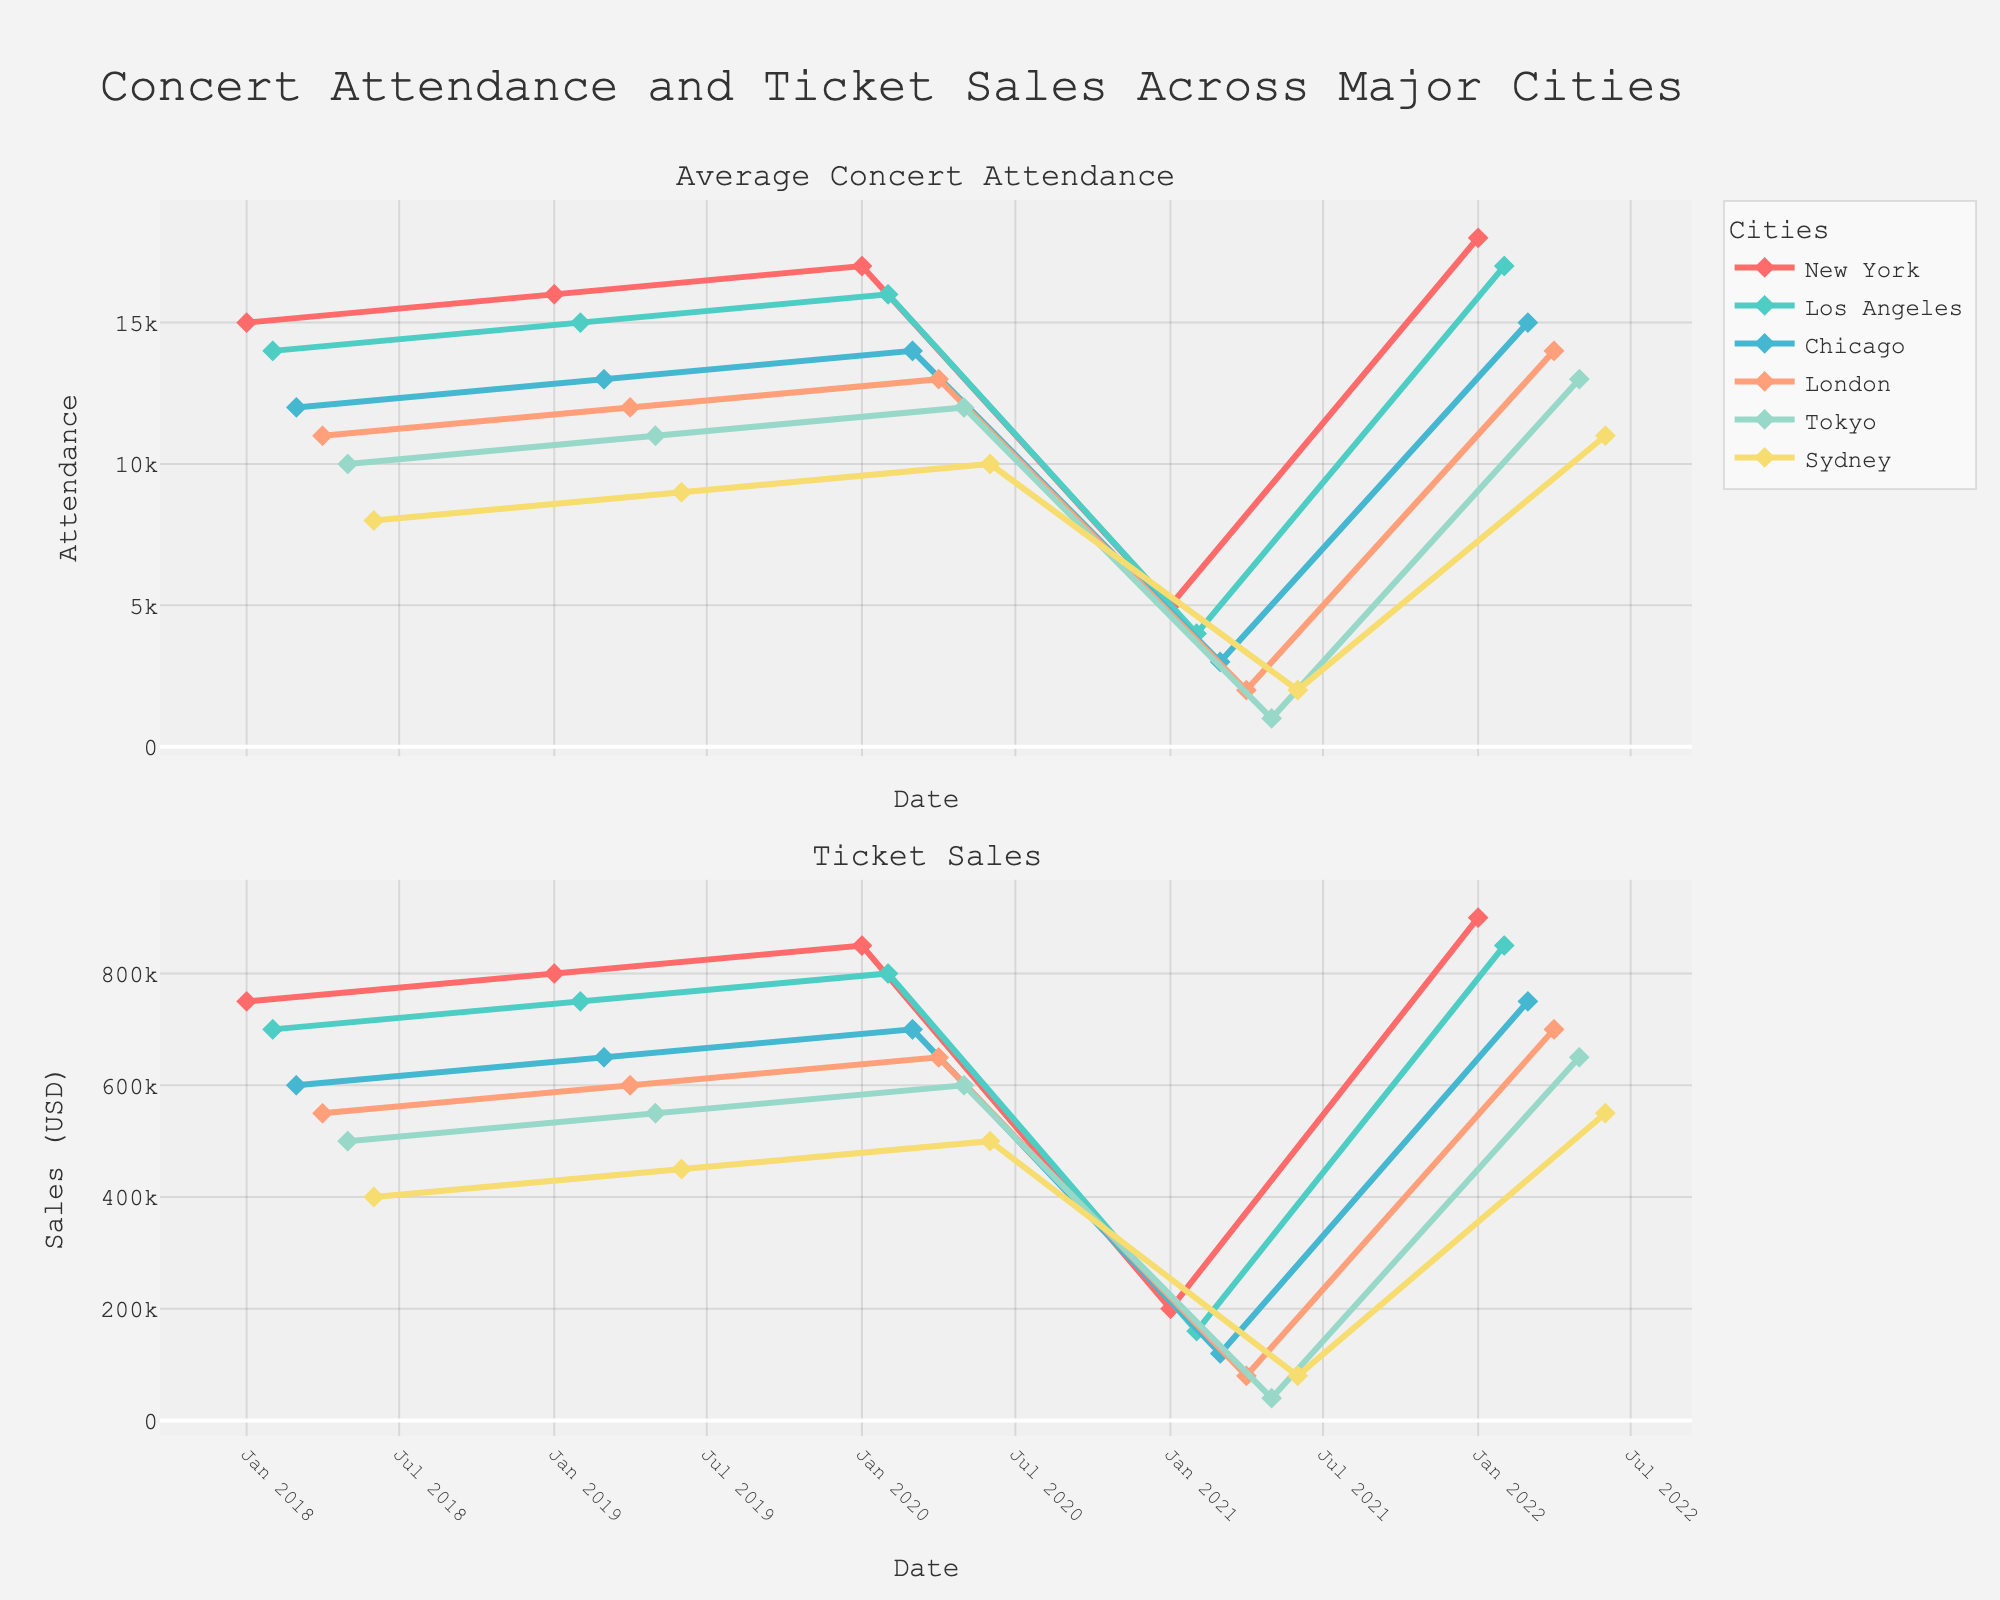What is the title of the figure? The title of the figure is located at the top and is typically in larger, bold font. We can see it reads "Concert Attendance and Ticket Sales Across Major Cities".
Answer: Concert Attendance and Ticket Sales Across Major Cities What time period does the figure cover for New York? To determine the covered time period, look at the dates on the x-axis for the "New York" data. The data points for New York span from January 2018 to January 2022.
Answer: January 2018 to January 2022 How did the concert attendance in Tokyo change from 2020 to 2021? By finding the data points for Tokyo in the upper subplot, we can see the attendance in May 2020 was 12,000 and it dropped to 1,000 in May 2021.
Answer: Dropped from 12,000 to 1,000 Which city had the lowest ticket sales in 2021 and how much was it? Observing the ticket sales plot (lower subplot), the lowest ticket sales in 2021 are seen in the spike for London. The noted sales amount was $80,000 in London (April 2021).
Answer: London, $80,000 Compare the concert attendance trends of New York and Los Angeles. Which city had a higher percentage drop in attendance in 2021 compared to 2020, and by how much? First, we calculate the drop for New York: from 17,000 (2020) to 5,000 (2021), giving a percentage drop of (17,000-5,000)/17,000 ≈ 70.59%. For Los Angeles, attendance dropped from 16,000 (2020) to 4,000 (2021), providing a percentage drop of (16,000-4,000)/16,000 = 75%. Los Angeles had the higher percentage drop by 4.41%.
Answer: Los Angeles, by 4.41% Which month and year did Sydney see a significant increase in both attendance and ticket sales compared to the previous year? Identify the month and year in the subplots where Sydney shows a jump in attendance and ticket sales compared to the previous year. The significant increase was in June 2022, compared to June 2021.
Answer: June 2022 How does the average concert attendance in 2019 compare across the cities? Refer to the points in the upper subplot for 2019. Compare the attendance figures for each city: New York (16,000), Los Angeles (15,000), Chicago (13,000), London (12,000), Tokyo (11,000), Sydney (9,000).
Answer: New York > Los Angeles > Chicago > London > Tokyo > Sydney What was the trend in ticket sales for London from 2018 to 2022? Following the trajectory of London's sales data points in the lower subplot, we can observe the ticket sales increased from 2018 to 2020, dropped significantly in 2021, and then sharply increased again in 2022.
Answer: Increase, drop, increase Considering all cities, which one had the highest concert attendance in 2022 and what was the figure? In the earliest time points of 2022 in the upper subplot, New York stands out with the highest attendance at 18,000 in January 2022.
Answer: New York, 18,000 Was there any year or city where both concert attendance and ticket sales did not follow the trend seen in other years or similar cities? 2021 appears as an anomaly where all cities experienced a significant drop in both attendance and ticket sales likely due to the global pandemic. This year contrasts sharply with the others.
Answer: 2021 